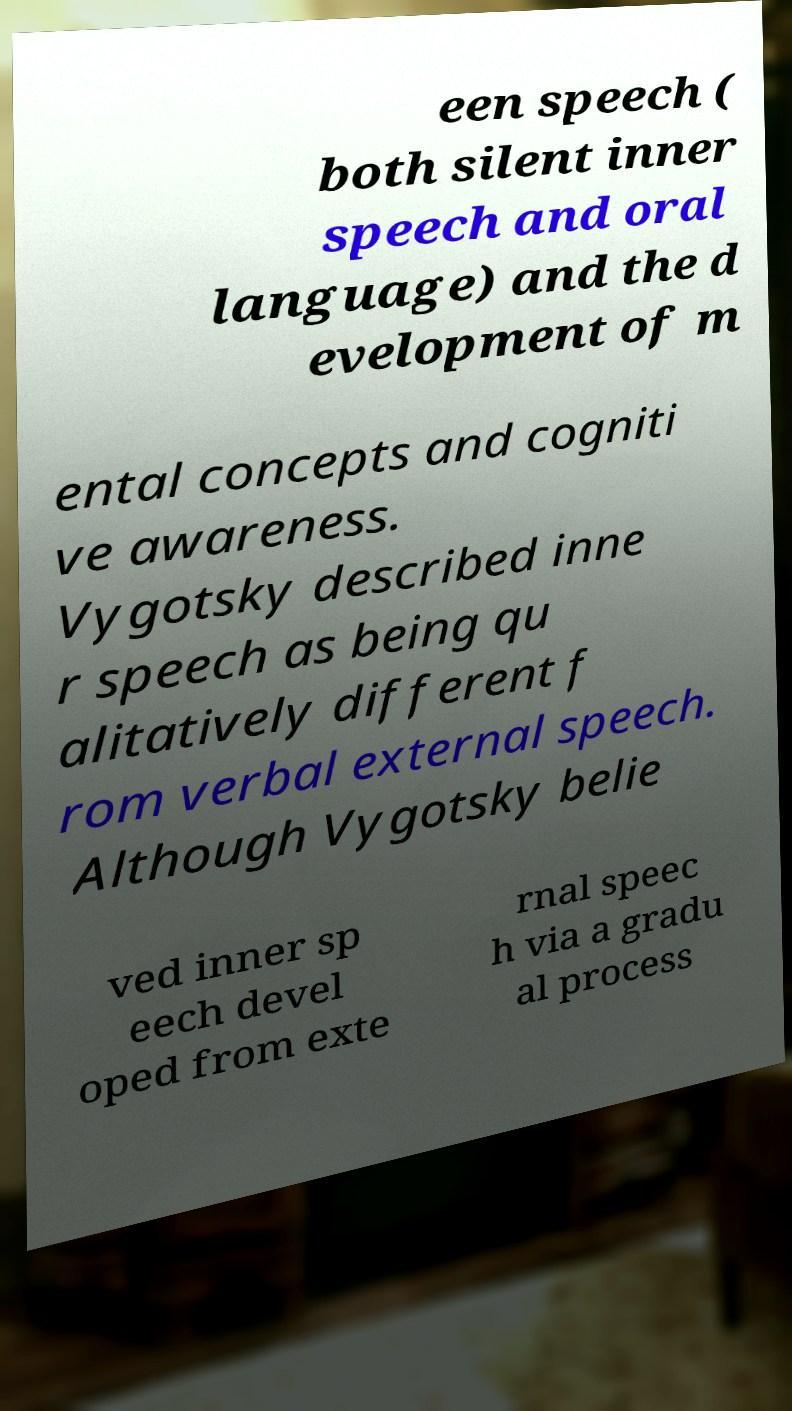There's text embedded in this image that I need extracted. Can you transcribe it verbatim? een speech ( both silent inner speech and oral language) and the d evelopment of m ental concepts and cogniti ve awareness. Vygotsky described inne r speech as being qu alitatively different f rom verbal external speech. Although Vygotsky belie ved inner sp eech devel oped from exte rnal speec h via a gradu al process 